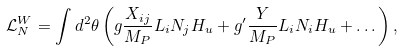<formula> <loc_0><loc_0><loc_500><loc_500>\mathcal { L } _ { N } ^ { W } = \int d ^ { 2 } \theta \left ( g \frac { X _ { i j } } { M _ { P } } L _ { i } N _ { j } H _ { u } + g ^ { \prime } \frac { Y } { M _ { P } } L _ { i } N _ { i } H _ { u } + \dots \right ) ,</formula> 